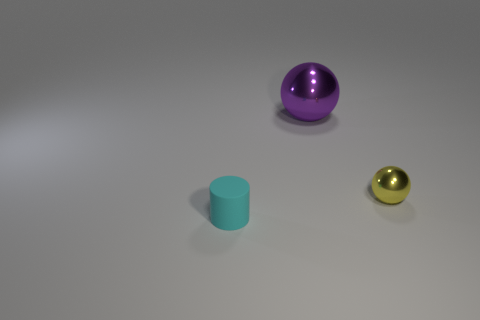What material is the other thing that is the same size as the yellow thing?
Offer a very short reply. Rubber. There is a sphere that is in front of the big purple sphere; is its size the same as the thing that is left of the big sphere?
Your answer should be very brief. Yes. Are there any yellow things made of the same material as the purple thing?
Your response must be concise. Yes. What number of things are small objects behind the cylinder or red things?
Your answer should be very brief. 1. Are the small thing that is behind the small matte cylinder and the cyan cylinder made of the same material?
Offer a very short reply. No. Do the big shiny thing and the small rubber thing have the same shape?
Provide a short and direct response. No. How many cylinders are left of the sphere to the right of the big sphere?
Provide a succinct answer. 1. There is another yellow object that is the same shape as the big shiny thing; what is it made of?
Your response must be concise. Metal. Is the big purple thing made of the same material as the tiny thing in front of the small yellow metallic object?
Offer a very short reply. No. What shape is the thing that is in front of the small yellow object?
Provide a short and direct response. Cylinder. 